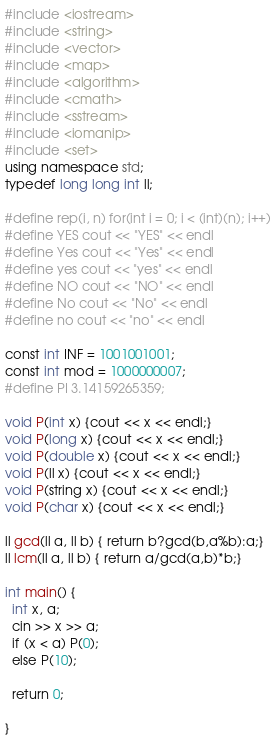Convert code to text. <code><loc_0><loc_0><loc_500><loc_500><_C++_>#include <iostream>
#include <string>
#include <vector>
#include <map>
#include <algorithm>
#include <cmath>
#include <sstream>
#include <iomanip>
#include <set>
using namespace std;
typedef long long int ll;

#define rep(i, n) for(int i = 0; i < (int)(n); i++)
#define YES cout << "YES" << endl
#define Yes cout << "Yes" << endl
#define yes cout << "yes" << endl
#define NO cout << "NO" << endl
#define No cout << "No" << endl
#define no cout << "no" << endl

const int INF = 1001001001;
const int mod = 1000000007;
#define PI 3.14159265359;

void P(int x) {cout << x << endl;}
void P(long x) {cout << x << endl;}
void P(double x) {cout << x << endl;}
void P(ll x) {cout << x << endl;}
void P(string x) {cout << x << endl;}
void P(char x) {cout << x << endl;}

ll gcd(ll a, ll b) { return b?gcd(b,a%b):a;}
ll lcm(ll a, ll b) { return a/gcd(a,b)*b;}

int main() {
  int x, a;
  cin >> x >> a;
  if (x < a) P(0);
  else P(10);

  return 0;

}</code> 